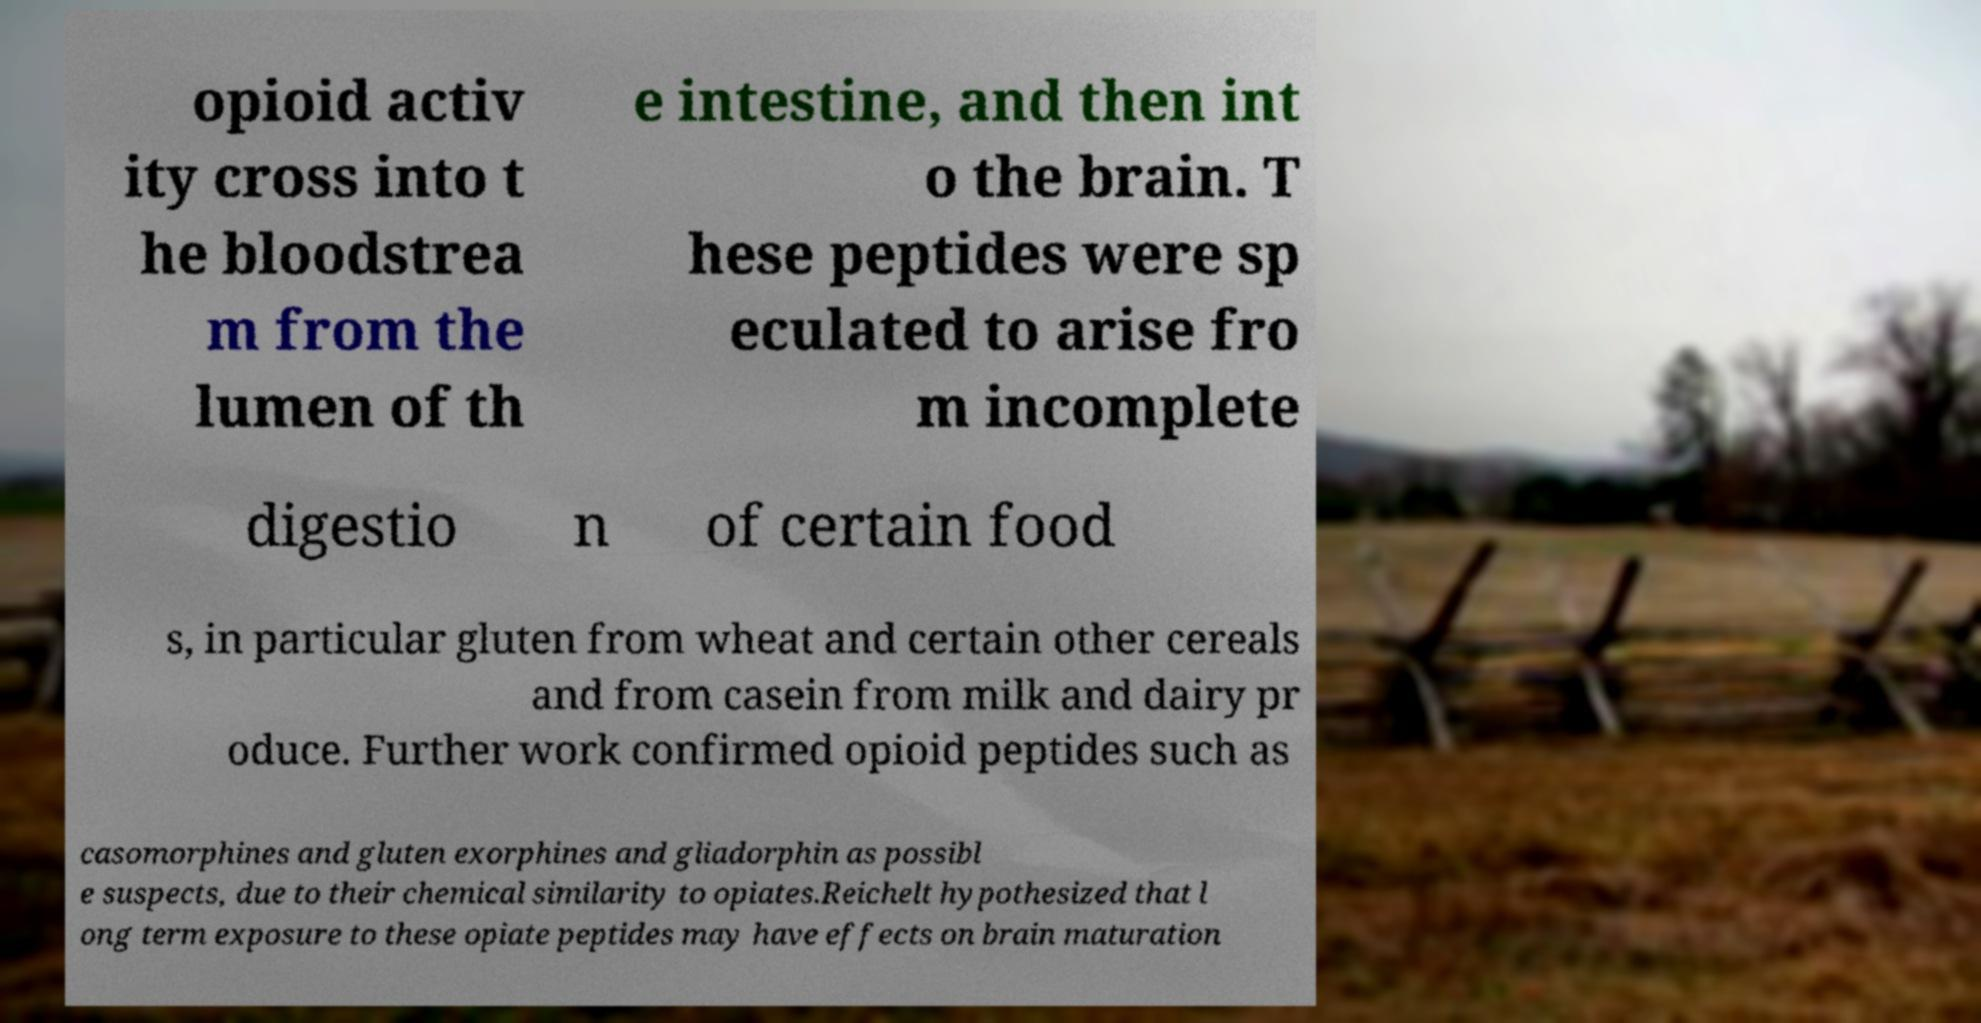Please identify and transcribe the text found in this image. opioid activ ity cross into t he bloodstrea m from the lumen of th e intestine, and then int o the brain. T hese peptides were sp eculated to arise fro m incomplete digestio n of certain food s, in particular gluten from wheat and certain other cereals and from casein from milk and dairy pr oduce. Further work confirmed opioid peptides such as casomorphines and gluten exorphines and gliadorphin as possibl e suspects, due to their chemical similarity to opiates.Reichelt hypothesized that l ong term exposure to these opiate peptides may have effects on brain maturation 